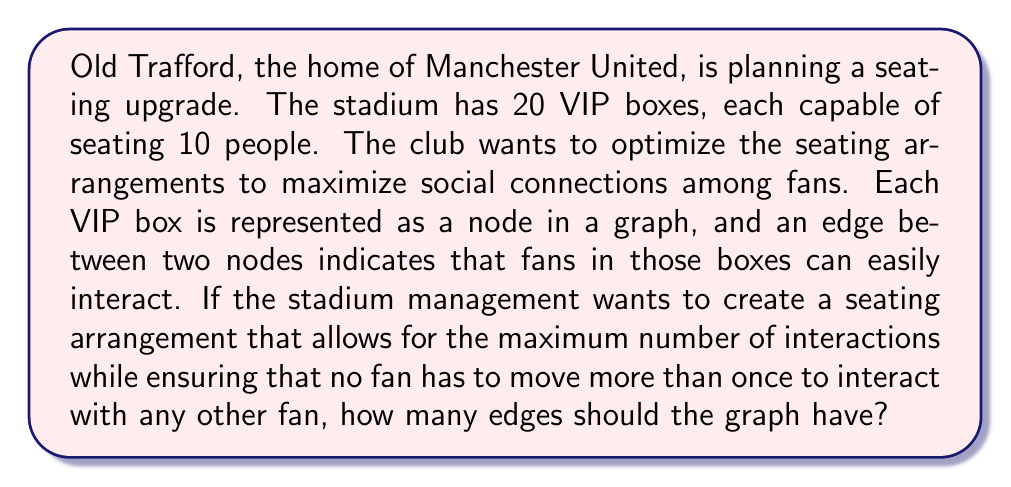Provide a solution to this math problem. To solve this problem, we need to use concepts from graph theory and combinatorics. Let's break it down step-by-step:

1) We have 20 VIP boxes, which means our graph has 20 nodes.

2) The condition "no fan has to move more than once to interact with any other fan" implies that the graph should have a diameter of 2. In graph theory, a graph with diameter 2 means that any two nodes are connected by a path of at most 2 edges.

3) To achieve a diameter of 2 with the maximum number of interactions (edges), we need to create a Moore graph. A Moore graph is an undirected graph with diameter $d$ and girth $2d+1$, where girth is the length of the shortest cycle in the graph.

4) For a Moore graph with diameter 2, the maximum possible degree $k$ of each node is given by the equation:

   $n = k^2 + 1$

   where $n$ is the number of nodes.

5) In our case, $n = 20$. Solving for $k$:

   $20 = k^2 + 1$
   $k^2 = 19$
   $k = \sqrt{19} \approx 4.36$

6) Since $k$ must be an integer, we round down to 4. This means each node should be connected to 4 other nodes.

7) The total number of edges in the graph can be calculated using the handshaking lemma:

   $E = \frac{nk}{2}$

   where $E$ is the number of edges, $n$ is the number of nodes, and $k$ is the degree of each node.

8) Substituting our values:

   $E = \frac{20 * 4}{2} = 40$

Therefore, the graph should have 40 edges to maximize interactions while ensuring no fan needs to move more than once to interact with any other fan.
Answer: The graph should have 40 edges. 